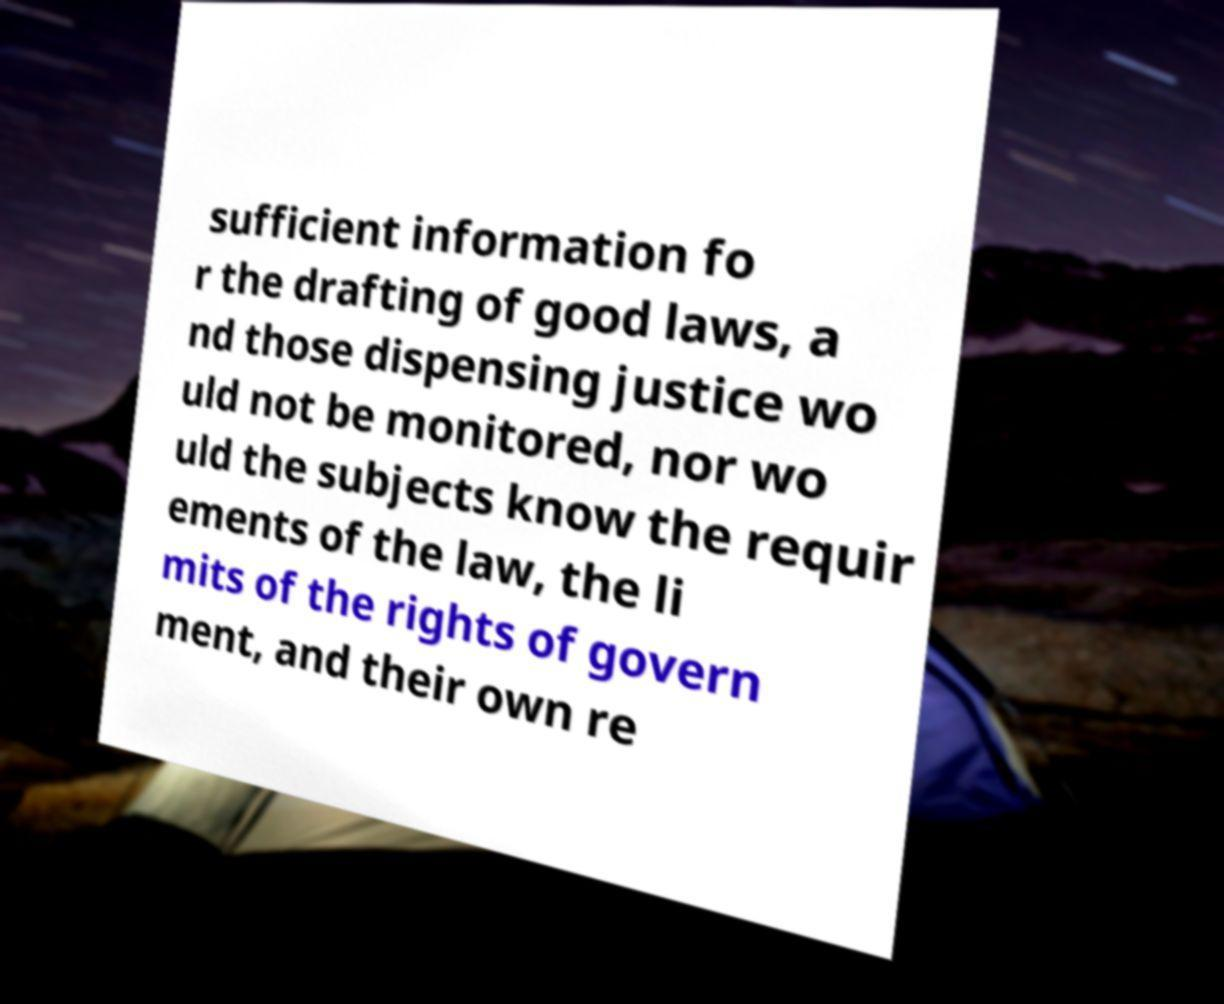Could you extract and type out the text from this image? sufficient information fo r the drafting of good laws, a nd those dispensing justice wo uld not be monitored, nor wo uld the subjects know the requir ements of the law, the li mits of the rights of govern ment, and their own re 